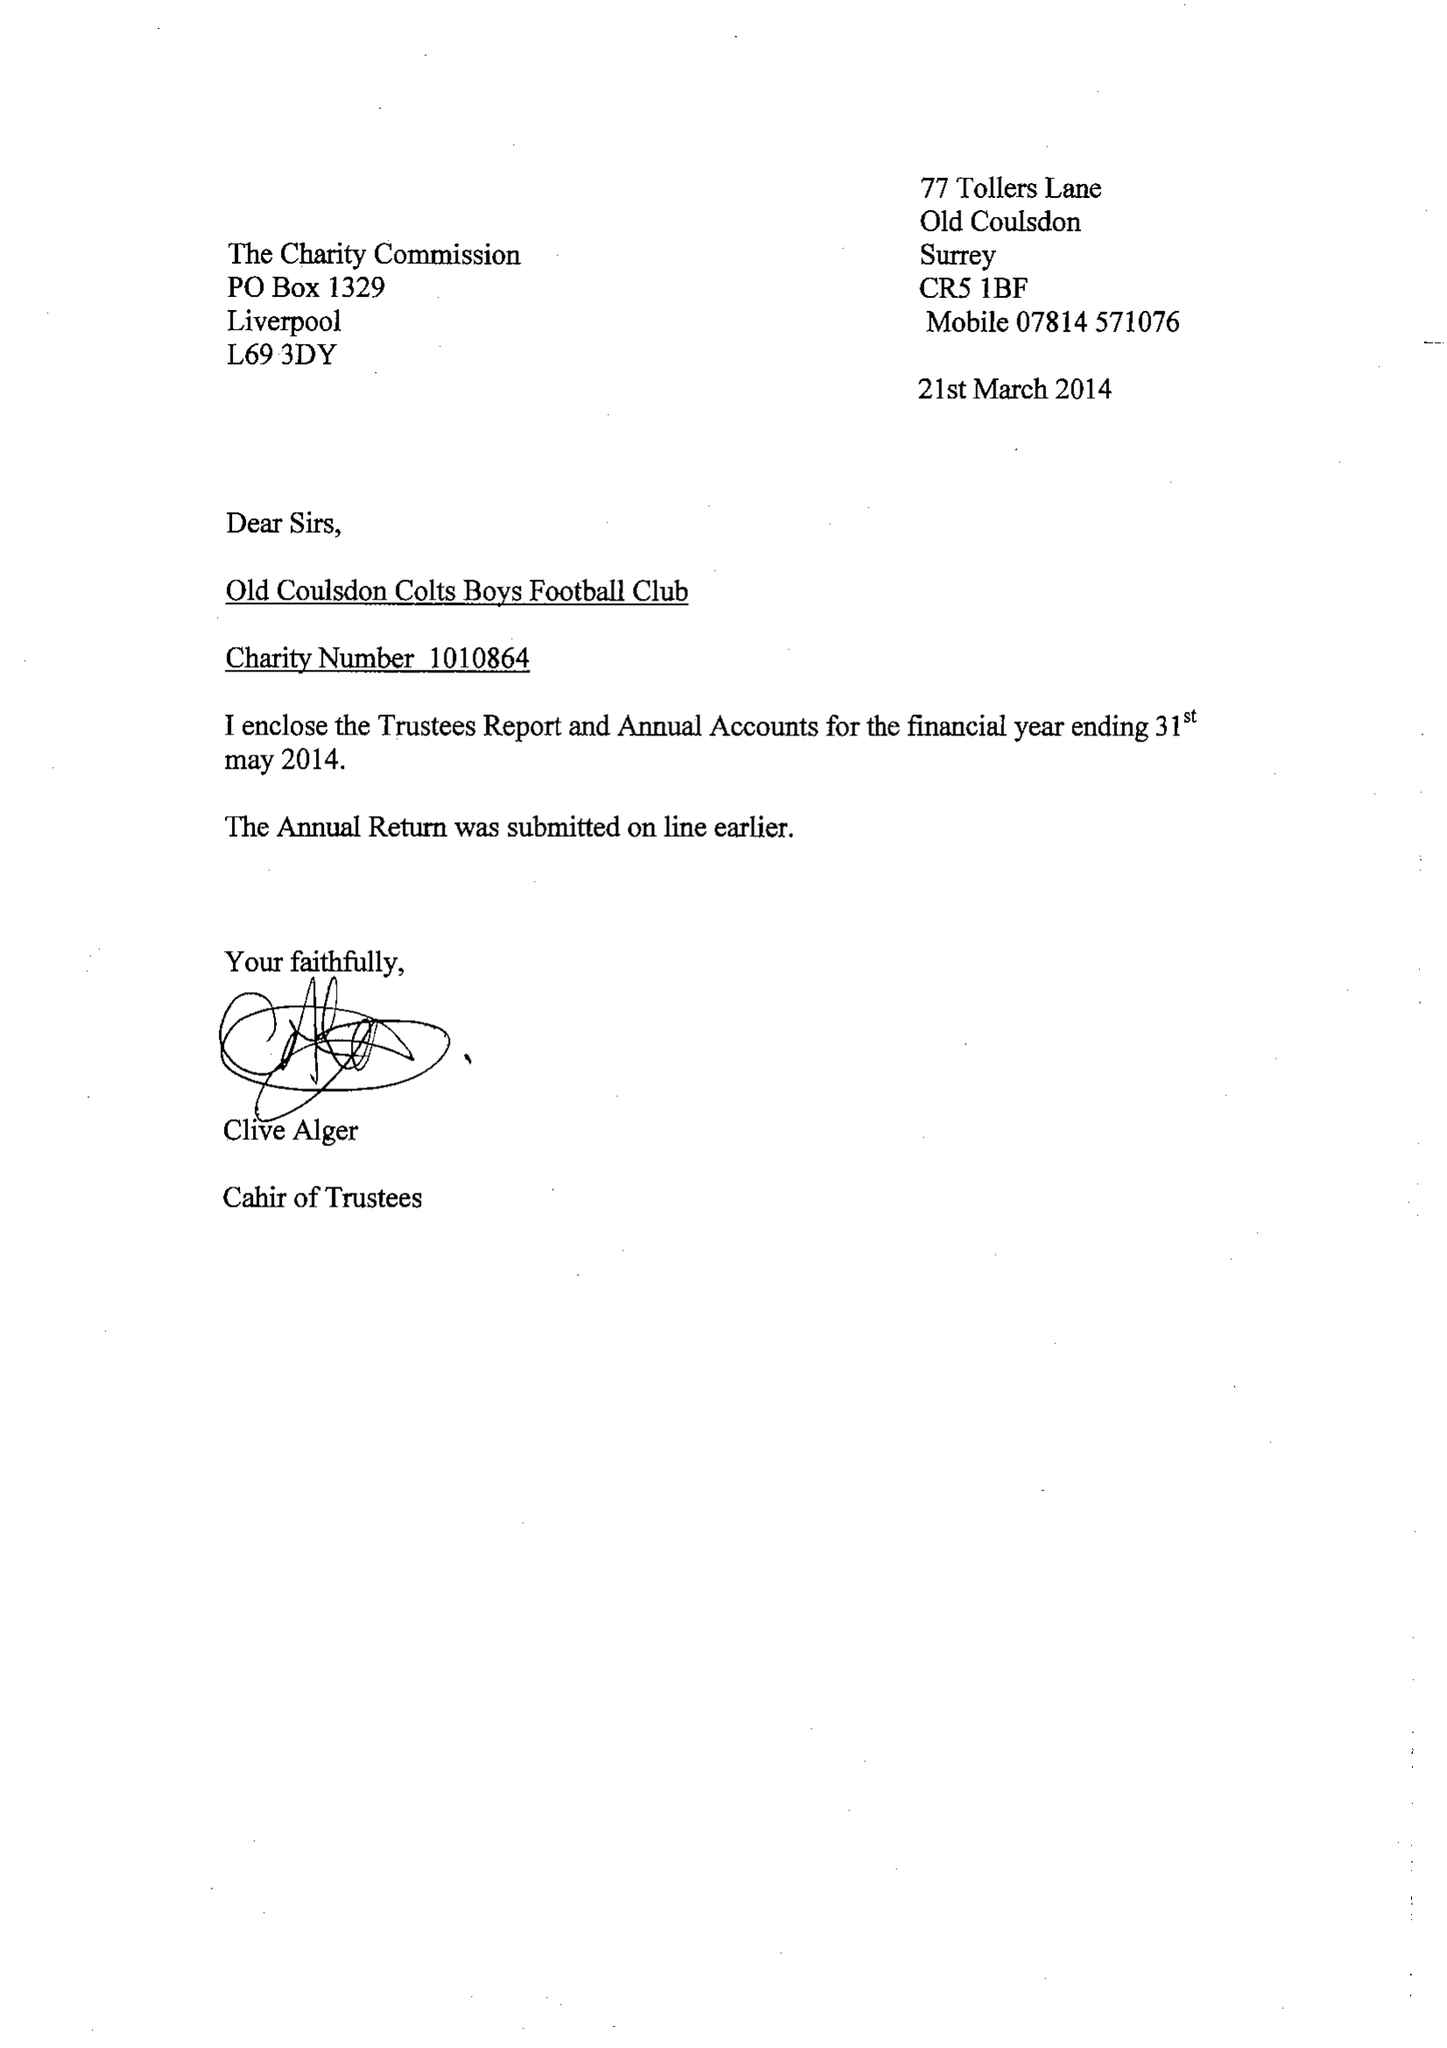What is the value for the spending_annually_in_british_pounds?
Answer the question using a single word or phrase. 45863.00 